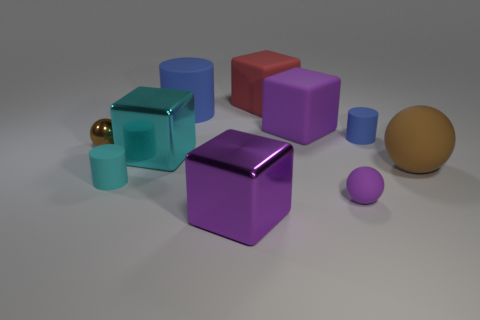How many big matte things are there? There are three large matte cubes visible in the image. The objects display a matte finish that diffuses the light, creating a softer appearance compared to a shiny, reflective surface. 